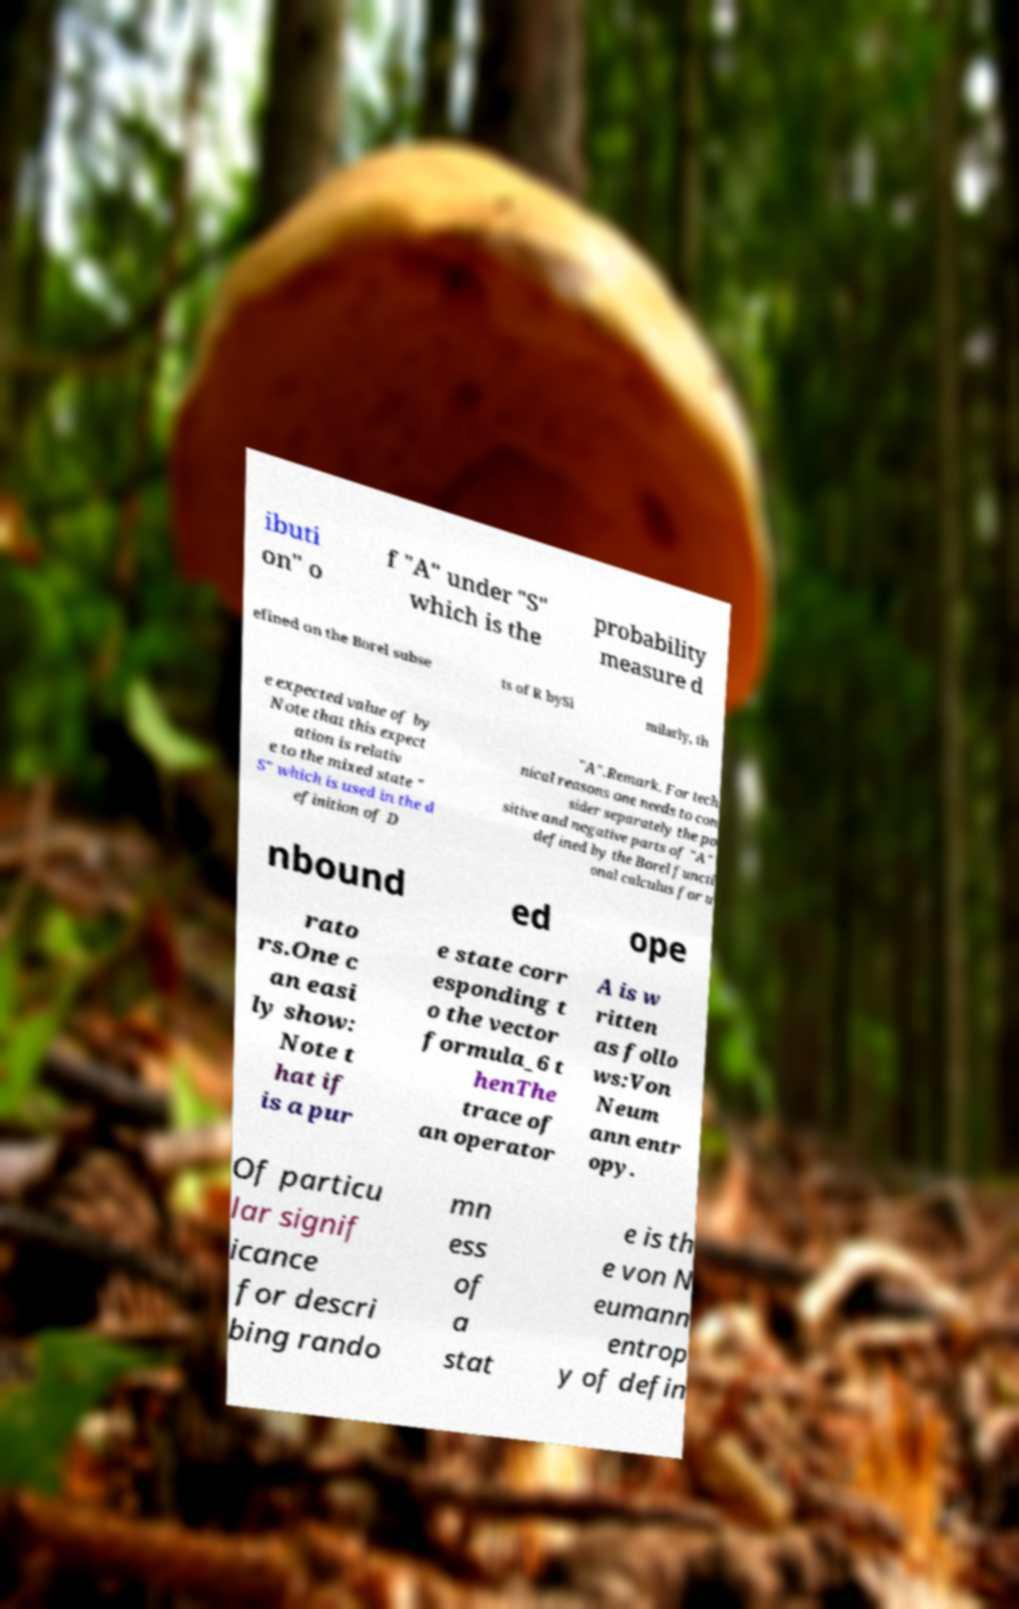Could you extract and type out the text from this image? ibuti on" o f "A" under "S" which is the probability measure d efined on the Borel subse ts of R bySi milarly, th e expected value of by Note that this expect ation is relativ e to the mixed state " S" which is used in the d efinition of D "A".Remark. For tech nical reasons one needs to con sider separately the po sitive and negative parts of "A" defined by the Borel functi onal calculus for u nbound ed ope rato rs.One c an easi ly show: Note t hat if is a pur e state corr esponding t o the vector formula_6 t henThe trace of an operator A is w ritten as follo ws:Von Neum ann entr opy. Of particu lar signif icance for descri bing rando mn ess of a stat e is th e von N eumann entrop y of defin 